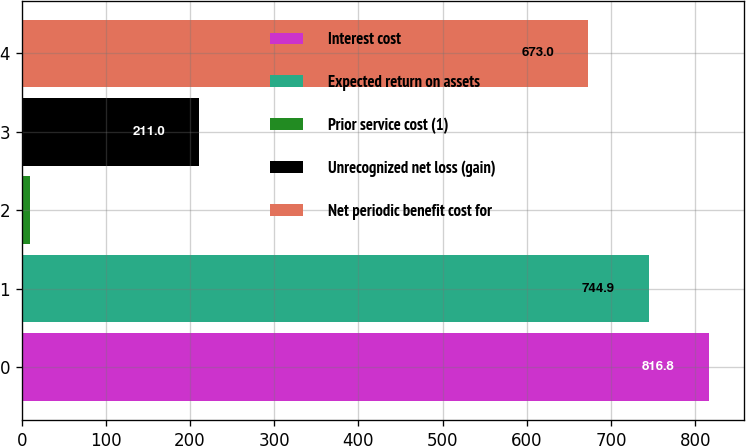Convert chart to OTSL. <chart><loc_0><loc_0><loc_500><loc_500><bar_chart><fcel>Interest cost<fcel>Expected return on assets<fcel>Prior service cost (1)<fcel>Unrecognized net loss (gain)<fcel>Net periodic benefit cost for<nl><fcel>816.8<fcel>744.9<fcel>10<fcel>211<fcel>673<nl></chart> 